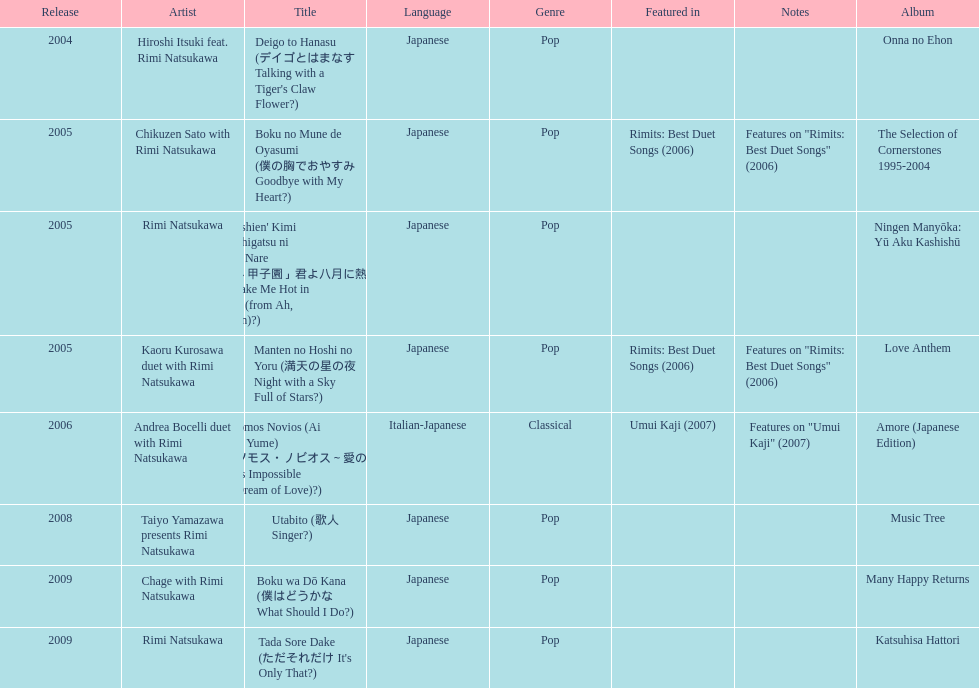Which title has the same notes as night with a sky full of stars? Boku no Mune de Oyasumi (僕の胸でおやすみ Goodbye with My Heart?). 